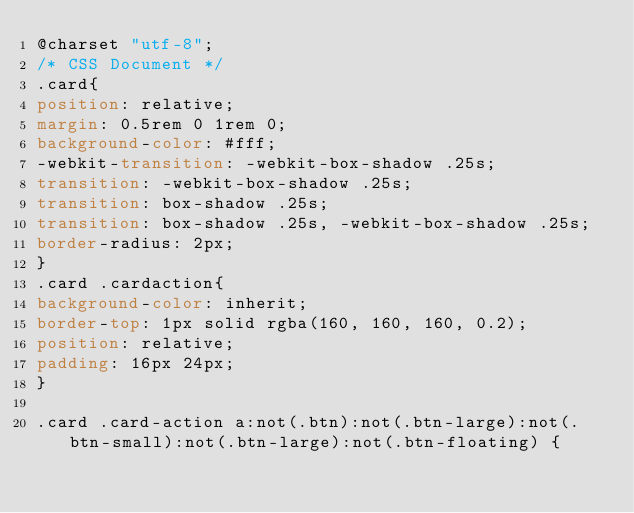Convert code to text. <code><loc_0><loc_0><loc_500><loc_500><_CSS_>@charset "utf-8";
/* CSS Document */
.card{
position: relative;
margin: 0.5rem 0 1rem 0;
background-color: #fff;
-webkit-transition: -webkit-box-shadow .25s;
transition: -webkit-box-shadow .25s;
transition: box-shadow .25s;
transition: box-shadow .25s, -webkit-box-shadow .25s;
border-radius: 2px;
}
.card .cardaction{
background-color: inherit;
border-top: 1px solid rgba(160, 160, 160, 0.2);
position: relative;
padding: 16px 24px;
}

.card .card-action a:not(.btn):not(.btn-large):not(.btn-small):not(.btn-large):not(.btn-floating) {</code> 